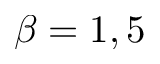<formula> <loc_0><loc_0><loc_500><loc_500>\beta = 1 , 5</formula> 